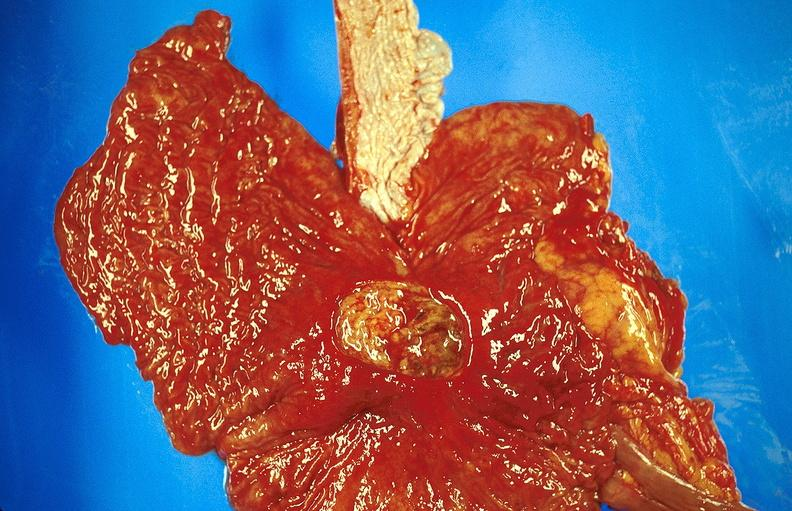does corpus luteum show gastric ulcer?
Answer the question using a single word or phrase. No 